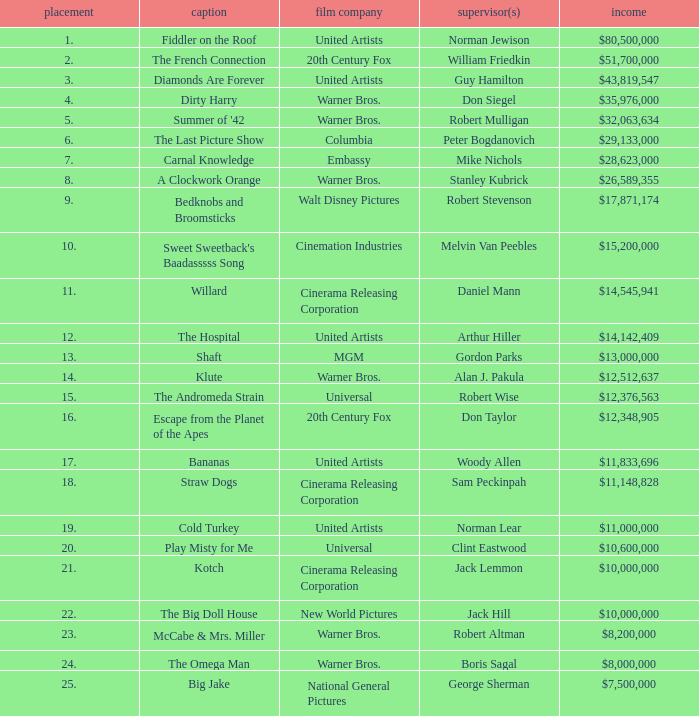What rank is the title with a gross of $26,589,355? 8.0. 